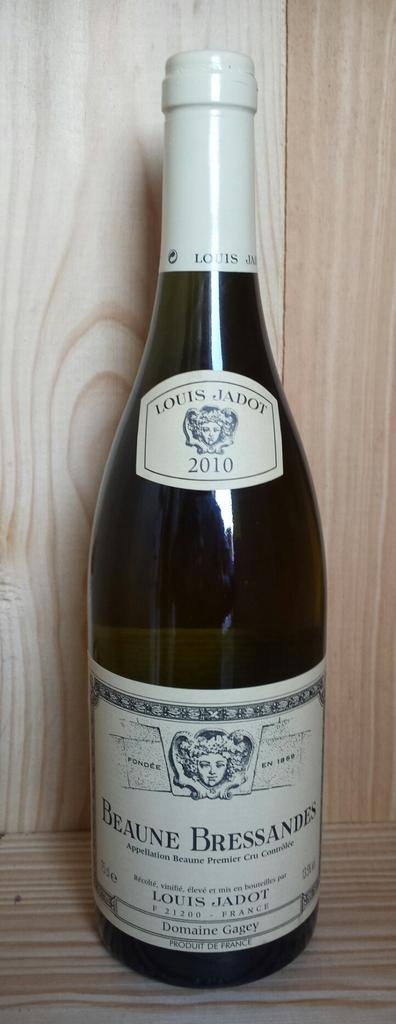<image>
Describe the image concisely. A bottle of wine from 2010 has a label that indicates it was made by Louis Jadot. 